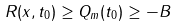<formula> <loc_0><loc_0><loc_500><loc_500>R ( x , t _ { 0 } ) \geq Q _ { m } ( t _ { 0 } ) \geq - B</formula> 